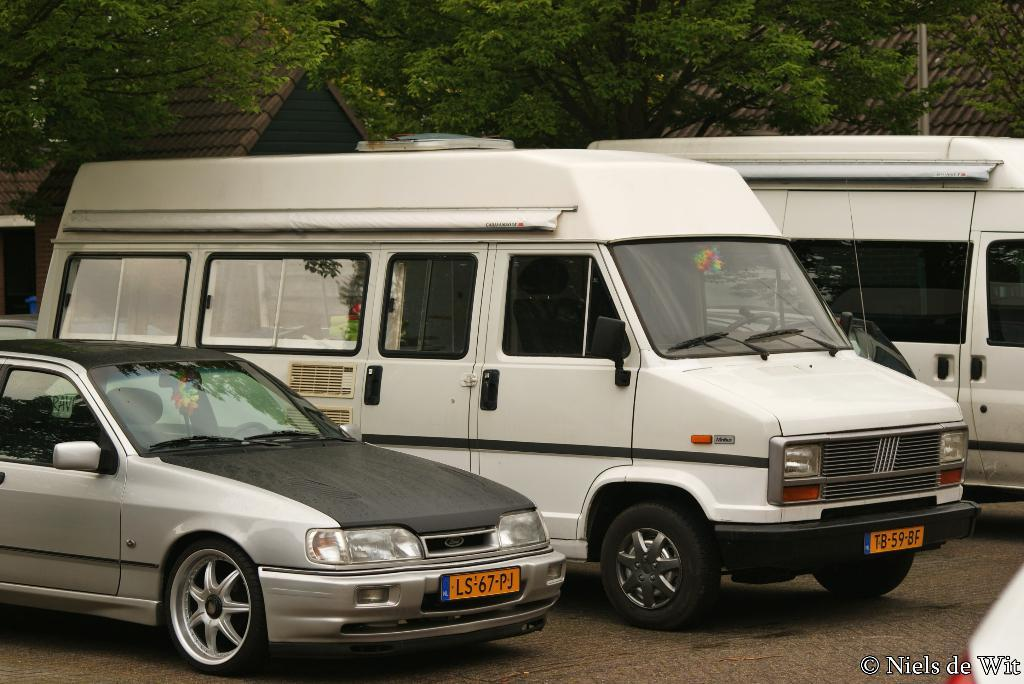<image>
Summarize the visual content of the image. Two white vans and a gray sedan are parked next to each other. 